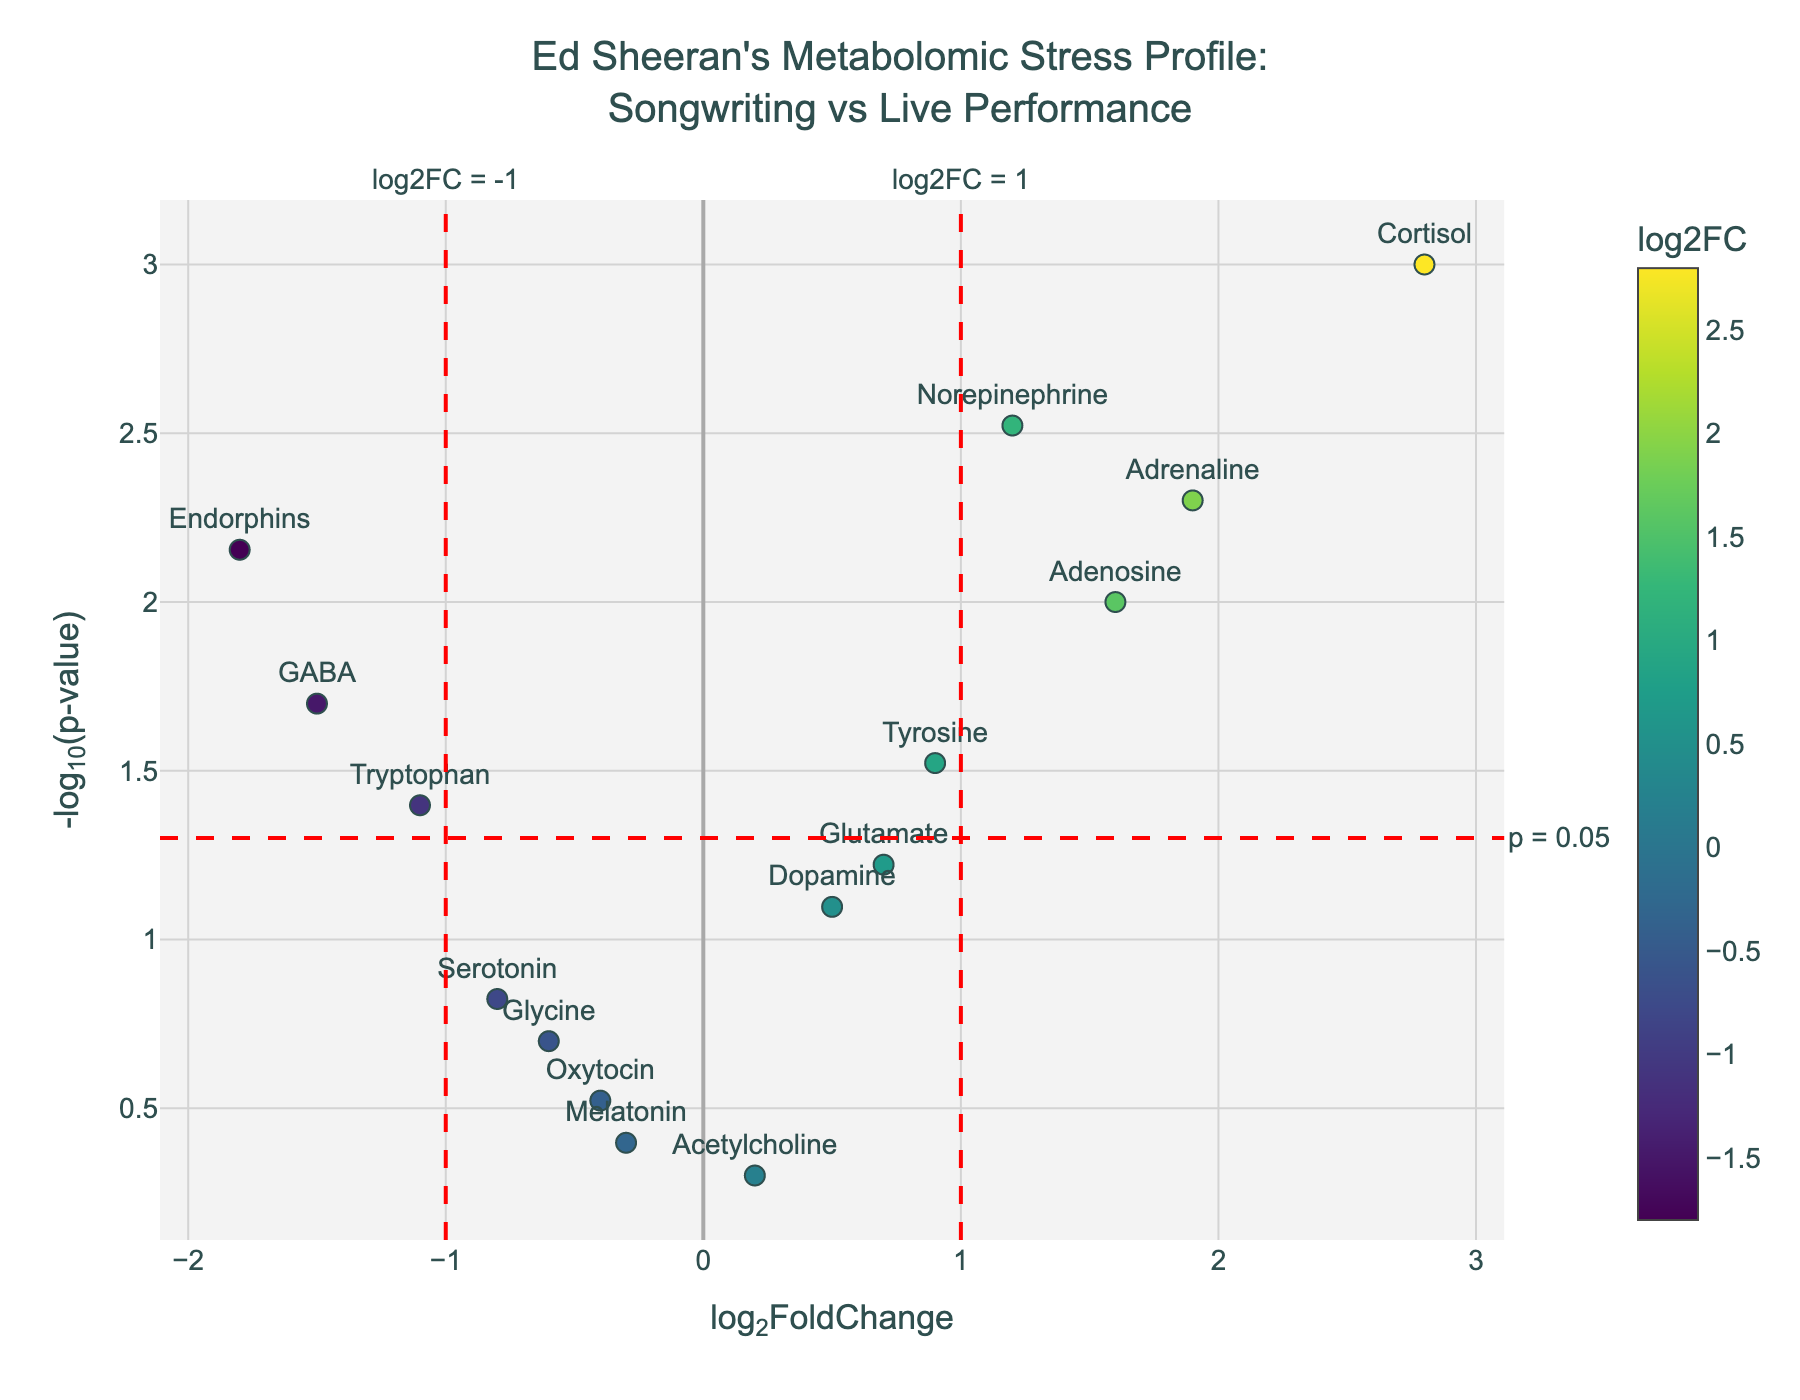What metabolite has the highest log2FoldChange value? The highest log2FoldChange value is represented by the data point farthest to the right along the x-axis. Cortisol has the highest log2FoldChange value of 2.8, as it is the rightmost data point.
Answer: Cortisol Which metabolite has the lowest p-value? The lowest p-value corresponds to the highest -log10(p-value) on the y-axis. Cortisol has the highest -log10(p-value) and therefore the lowest p-value of 0.001.
Answer: Cortisol How many metabolites have a log2FoldChange greater than 1? We look for data points to the right of the vertical line at log2FoldChange = 1. Cortisol, Adrenaline, Norepinephrine, and Adenosine have log2FoldChange values greater than 1.
Answer: 4 What is the title of the plot? The title is usually located at the top of the plot. This plot's title is "Ed Sheeran's Metabolomic Stress Profile: Songwriting vs Live Performance."
Answer: Ed Sheeran's Metabolomic Stress Profile: Songwriting vs Live Performance Which metabolite has the most significant negative log2FoldChange value? The most significant negative log2FoldChange value is represented by the data point farthest to the left along the x-axis. Endorphins have the lowest log2FoldChange value of -1.8.
Answer: Endorphins What does the horizontal dashed red line at y = -log10(0.05) signify? The horizontal dashed red line represents a significance threshold with a p-value of 0.05. Data points above this line have p-values less than 0.05.
Answer: Significance threshold (p = 0.05) Which metabolites have p-values less than 0.05 and both positive and negative log2FoldChange? We identify metabolites with data points above the horizontal threshold line at -log10(0.05) and check their log2FoldChange values. Cortisol, Adrenaline, Norepinephrine, Adenosine (positive log2FoldChange) and GABA, Tryptophan, Endorphins (negative log2FoldChange) meet both criteria.
Answer: Cortisol, Adrenaline, Norepinephrine, Adenosine, GABA, Tryptophan, Endorphins What is the color of the marker with the highest p-value? The color of a marker corresponds to its log2FoldChange value. Melatonin has the highest p-value of 0.4 and the smallest -log10(p-value) among visible data points, indicating it is likely represented by the dullest color on the color scale.
Answer: Dull color (e.g., near the middle of the colorscale) Compare the stress indicators Cortisol and Melatonin based on their log2FoldChange and p-values. Cortisol has a log2FoldChange of 2.8 (most elevated) and a p-value of 0.001 (most significant), placing it far right and high on the plot. Melatonin has a log2FoldChange of -0.3 and a p-value of 0.4, placing it near the middle and low on the plot. Cortisol indicates a higher and more significant stress level difference.
Answer: Cortisol: 2.8 log2FC, 0.001 p-value; Melatonin: -0.3 log2FC, 0.4 p-value 